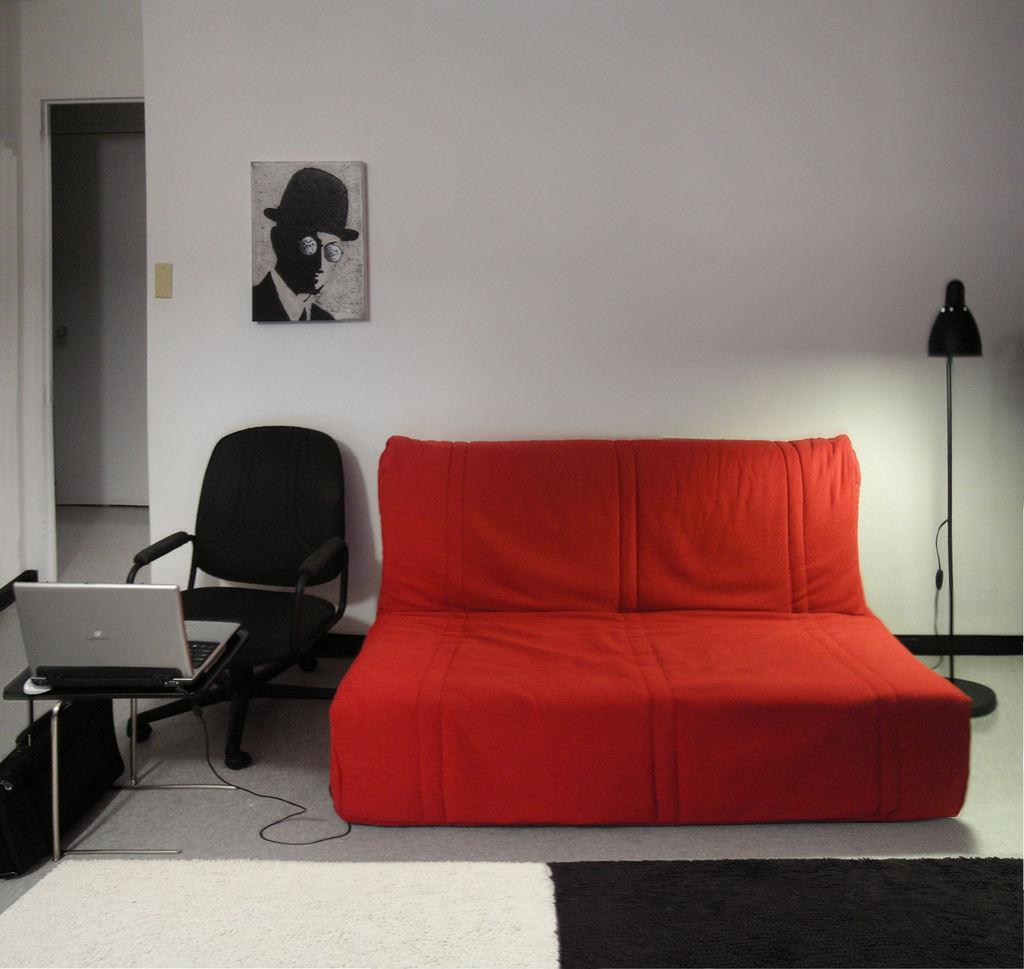Please provide a concise description of this image. In the image we can see there is a red colour bed and beside it there is a chair and in front of it there is a table on which laptop is kept and at the back the wall is in white colour. 